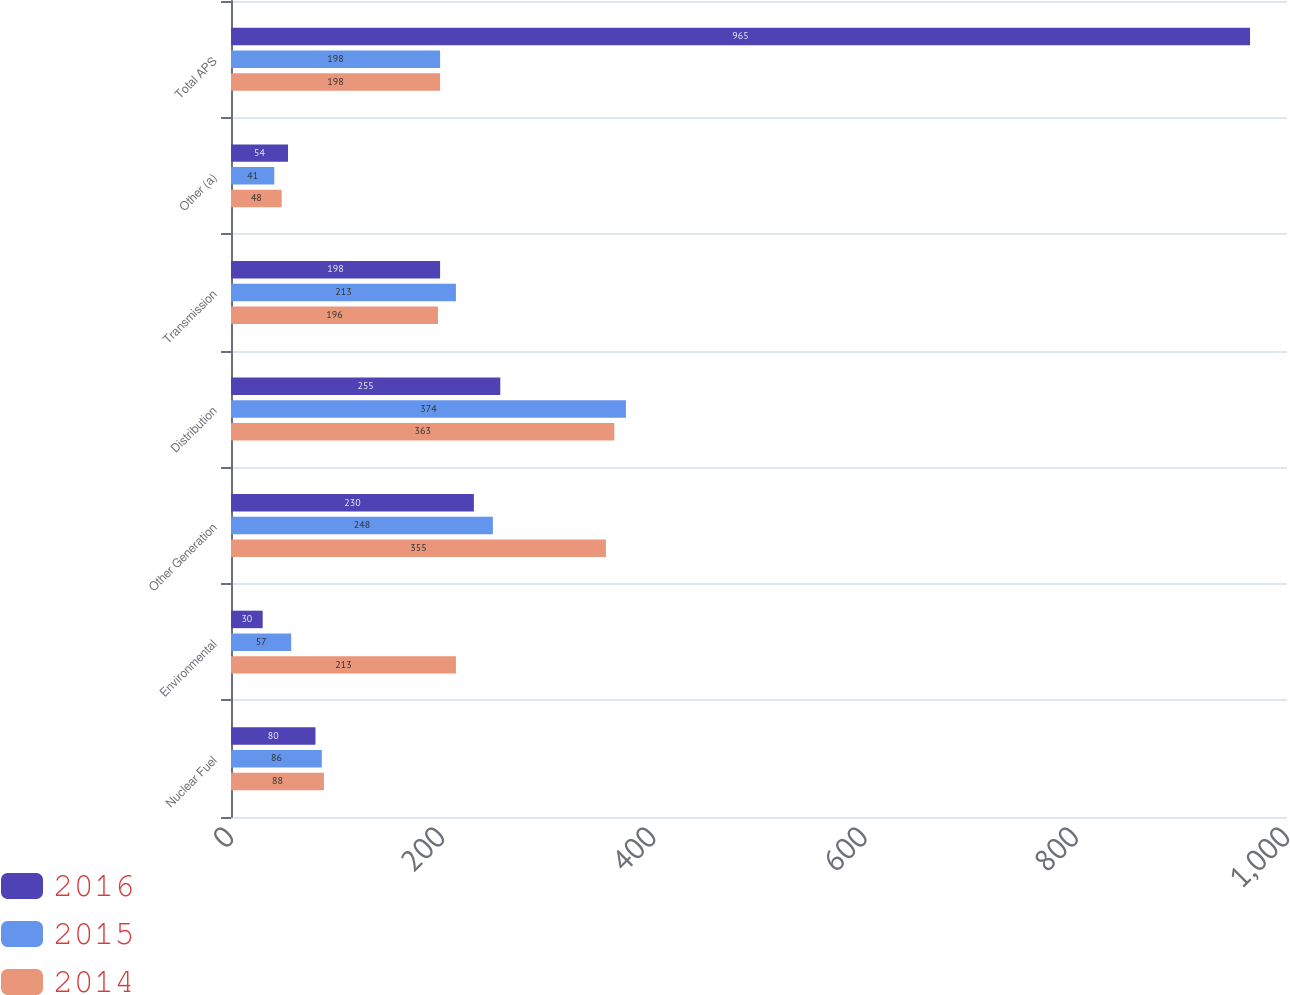Convert chart to OTSL. <chart><loc_0><loc_0><loc_500><loc_500><stacked_bar_chart><ecel><fcel>Nuclear Fuel<fcel>Environmental<fcel>Other Generation<fcel>Distribution<fcel>Transmission<fcel>Other (a)<fcel>Total APS<nl><fcel>2016<fcel>80<fcel>30<fcel>230<fcel>255<fcel>198<fcel>54<fcel>965<nl><fcel>2015<fcel>86<fcel>57<fcel>248<fcel>374<fcel>213<fcel>41<fcel>198<nl><fcel>2014<fcel>88<fcel>213<fcel>355<fcel>363<fcel>196<fcel>48<fcel>198<nl></chart> 